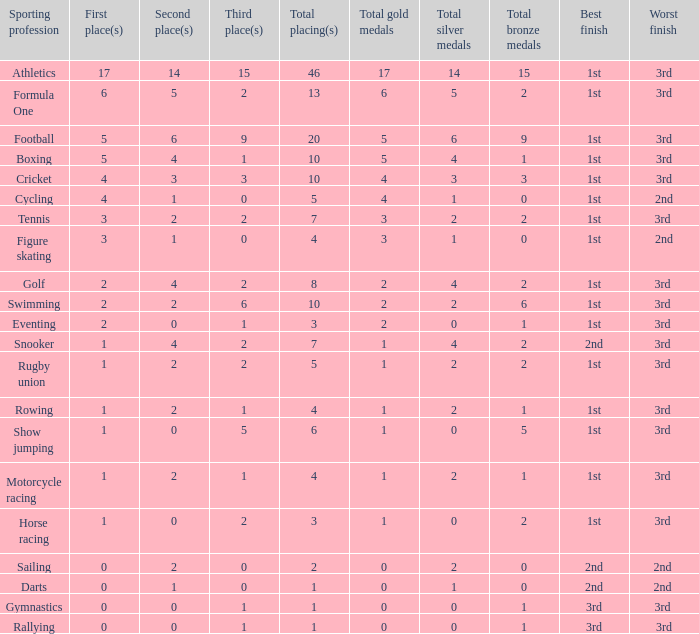What is the total number of 3rd place entries that have exactly 8 total placings? 1.0. 